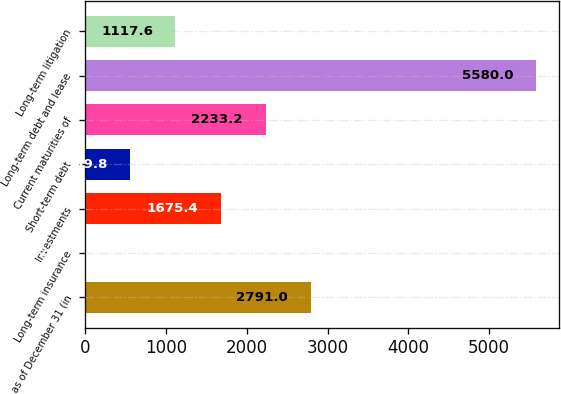Convert chart to OTSL. <chart><loc_0><loc_0><loc_500><loc_500><bar_chart><fcel>as of December 31 (in<fcel>Long-term insurance<fcel>Investments<fcel>Short-term debt<fcel>Current maturities of<fcel>Long-term debt and lease<fcel>Long-term litigation<nl><fcel>2791<fcel>2<fcel>1675.4<fcel>559.8<fcel>2233.2<fcel>5580<fcel>1117.6<nl></chart> 